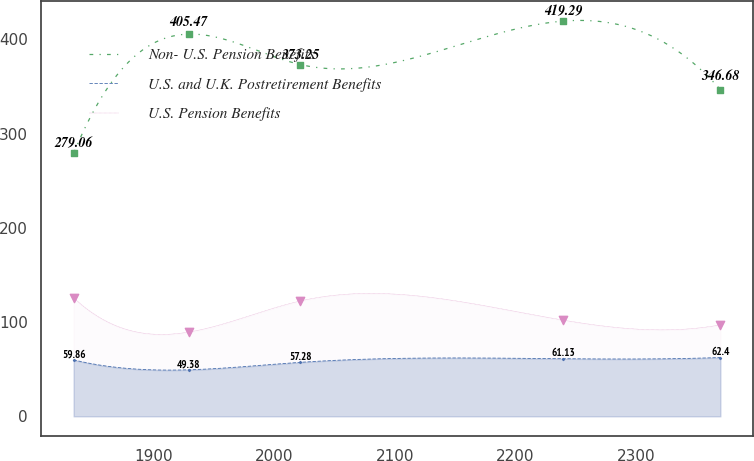Convert chart to OTSL. <chart><loc_0><loc_0><loc_500><loc_500><line_chart><ecel><fcel>Non- U.S. Pension Benefits<fcel>U.S. and U.K. Postretirement Benefits<fcel>U.S. Pension Benefits<nl><fcel>1834<fcel>279.06<fcel>59.86<fcel>125.79<nl><fcel>1929.54<fcel>405.47<fcel>49.38<fcel>89.45<nl><fcel>2021.62<fcel>373.25<fcel>57.28<fcel>122.38<nl><fcel>2239.43<fcel>419.29<fcel>61.13<fcel>102.06<nl><fcel>2369.59<fcel>346.68<fcel>62.4<fcel>97.06<nl></chart> 